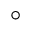<formula> <loc_0><loc_0><loc_500><loc_500>^ { \circ }</formula> 